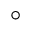<formula> <loc_0><loc_0><loc_500><loc_500>^ { \circ }</formula> 